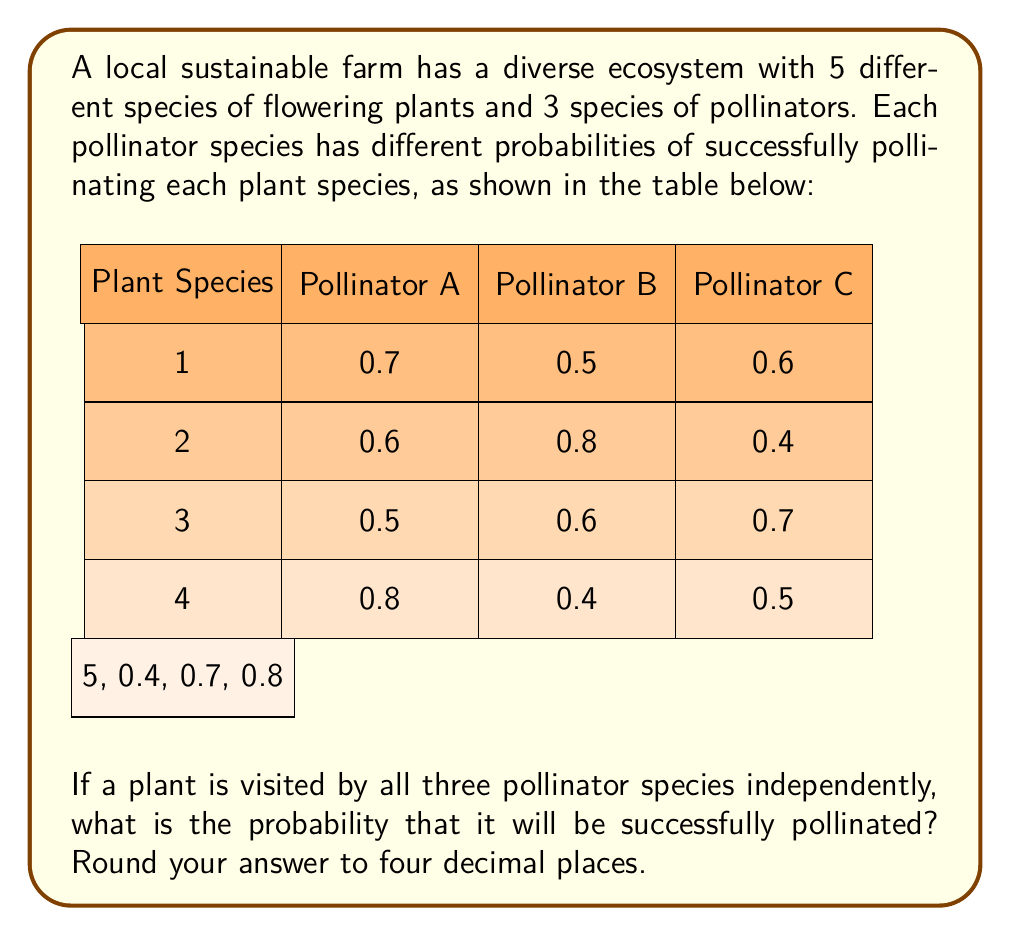Could you help me with this problem? Let's approach this step-by-step:

1) For a plant to be successfully pollinated, at least one of the pollinators needs to succeed. 

2) It's easier to calculate the probability of the plant not being pollinated and then subtract this from 1.

3) For each plant species, the probability of not being pollinated is the product of the probabilities of each pollinator failing.

4) Let's calculate this for each plant species:

   Plant 1: $P(\text{not pollinated}) = (1-0.7)(1-0.5)(1-0.6) = 0.3 \times 0.5 \times 0.4 = 0.06$
   Plant 2: $P(\text{not pollinated}) = (1-0.6)(1-0.8)(1-0.4) = 0.4 \times 0.2 \times 0.6 = 0.048$
   Plant 3: $P(\text{not pollinated}) = (1-0.5)(1-0.6)(1-0.7) = 0.5 \times 0.4 \times 0.3 = 0.06$
   Plant 4: $P(\text{not pollinated}) = (1-0.8)(1-0.4)(1-0.5) = 0.2 \times 0.6 \times 0.5 = 0.06$
   Plant 5: $P(\text{not pollinated}) = (1-0.4)(1-0.7)(1-0.8) = 0.6 \times 0.3 \times 0.2 = 0.036$

5) The probability of being pollinated for each plant is 1 minus these values:

   Plant 1: $1 - 0.06 = 0.94$
   Plant 2: $1 - 0.048 = 0.952$
   Plant 3: $1 - 0.06 = 0.94$
   Plant 4: $1 - 0.06 = 0.94$
   Plant 5: $1 - 0.036 = 0.964$

6) To find the average probability across all plant species, we sum these probabilities and divide by the number of plant species:

   $\frac{0.94 + 0.952 + 0.94 + 0.94 + 0.964}{5} = \frac{4.736}{5} = 0.9472$

7) Rounding to four decimal places gives us 0.9472.
Answer: 0.9472 